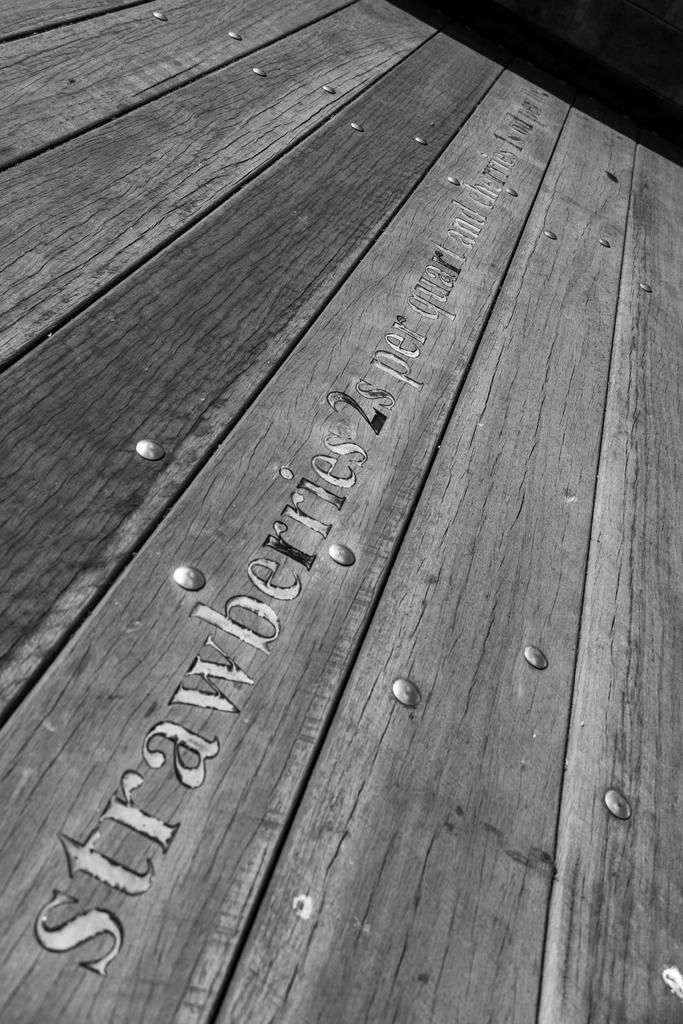<image>
Provide a brief description of the given image. Wood boards with Strawberries2s per quart and cherries engraved. 